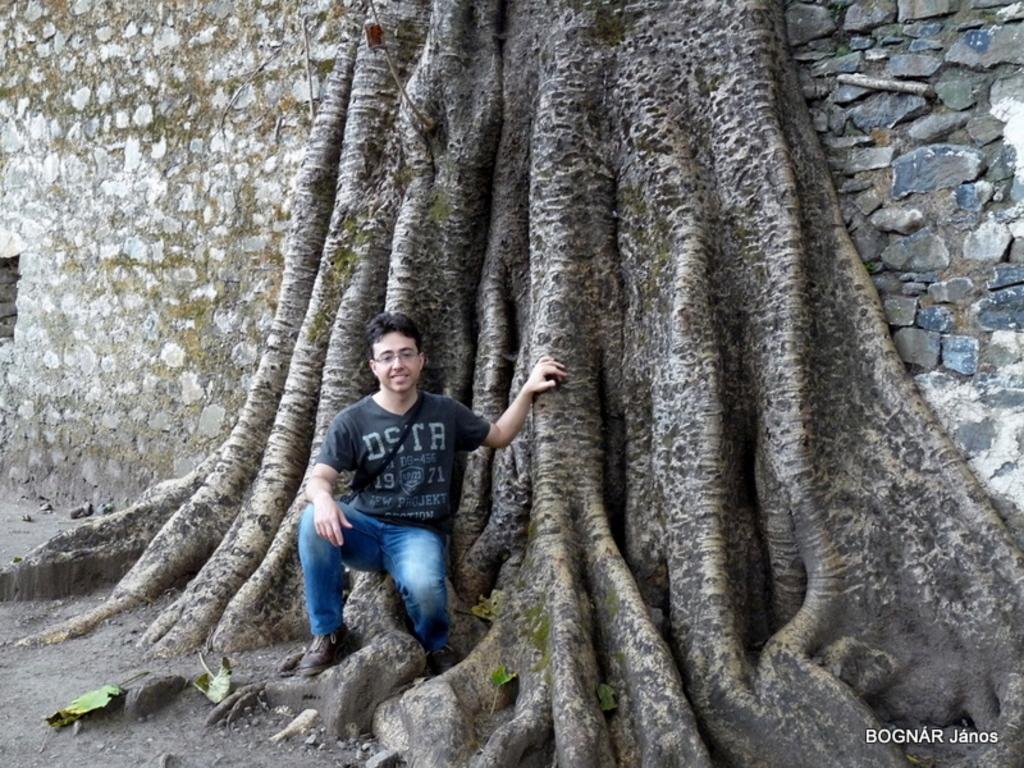Could you give a brief overview of what you see in this image? In the foreground of this image, there is a man squatting and in the background, there is a tree trunk and a brick wall. 